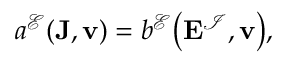Convert formula to latex. <formula><loc_0><loc_0><loc_500><loc_500>\begin{array} { r } { a ^ { \mathcal { E } } ( J , v ) = b ^ { \mathcal { E } } \left ( E ^ { \mathcal { I } } , v \right ) , } \end{array}</formula> 